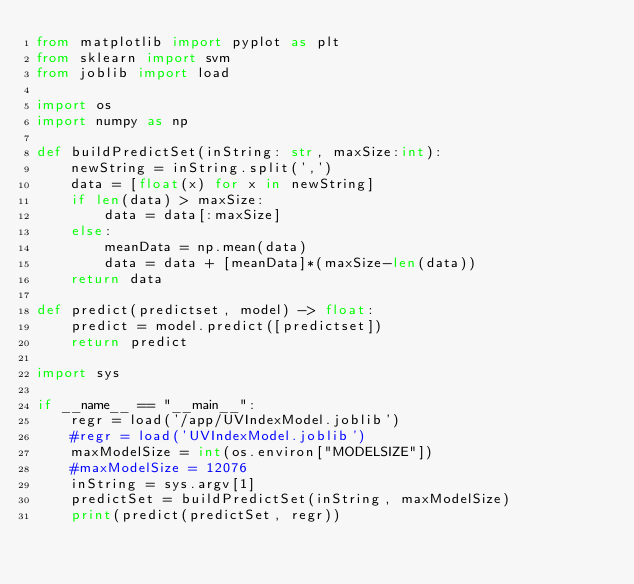<code> <loc_0><loc_0><loc_500><loc_500><_Python_>from matplotlib import pyplot as plt
from sklearn import svm
from joblib import load

import os
import numpy as np

def buildPredictSet(inString: str, maxSize:int):
    newString = inString.split(',')
    data = [float(x) for x in newString]
    if len(data) > maxSize:
        data = data[:maxSize]
    else:
        meanData = np.mean(data)
        data = data + [meanData]*(maxSize-len(data))
    return data

def predict(predictset, model) -> float:
    predict = model.predict([predictset])
    return predict

import sys

if __name__ == "__main__":
    regr = load('/app/UVIndexModel.joblib') 
    #regr = load('UVIndexModel.joblib') 
    maxModelSize = int(os.environ["MODELSIZE"])
    #maxModelSize = 12076
    inString = sys.argv[1]
    predictSet = buildPredictSet(inString, maxModelSize)
    print(predict(predictSet, regr))
</code> 